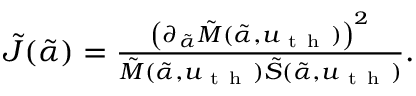<formula> <loc_0><loc_0><loc_500><loc_500>\begin{array} { r } { \tilde { J } ( \tilde { \alpha } ) = \frac { \left ( \partial _ { \tilde { \alpha } } \tilde { M } ( \tilde { \alpha } , u _ { t h } ) \right ) ^ { 2 } } { \tilde { M } ( \tilde { \alpha } , u _ { t h } ) \tilde { S } ( \tilde { \alpha } , u _ { t h } ) } . } \end{array}</formula> 